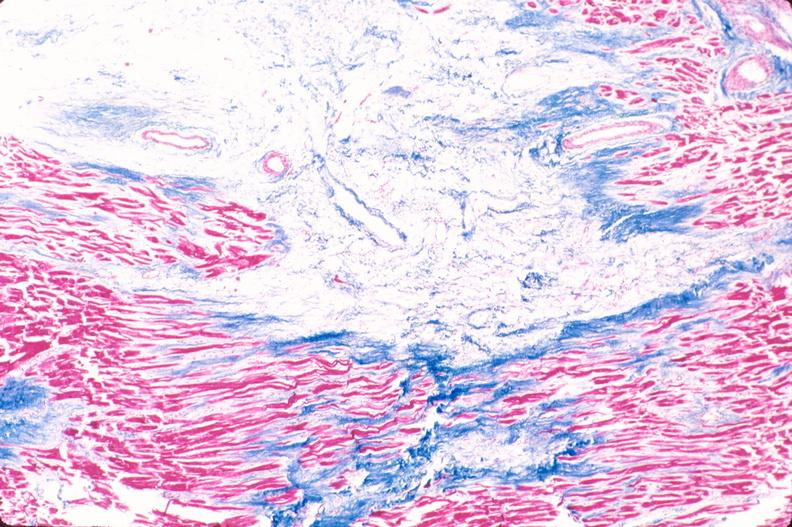what does this image show?
Answer the question using a single word or phrase. Heart 